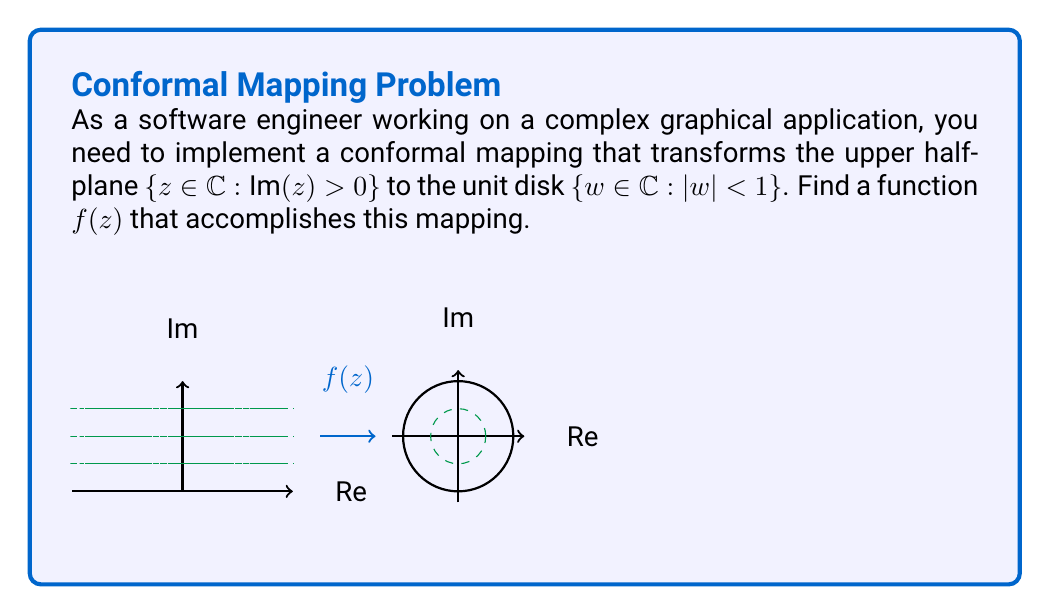Can you solve this math problem? Let's approach this step-by-step:

1) We need a function that maps the upper half-plane to the unit disk. A common function for this is the Möbius transformation.

2) The general form of a Möbius transformation is:

   $$f(z) = \frac{az + b}{cz + d}$$

   where $a$, $b$, $c$, and $d$ are complex constants and $ad - bc \neq 0$.

3) For our specific mapping, we can use:

   $$f(z) = \frac{z - i}{z + i}$$

4) Let's verify that this function indeed maps the upper half-plane to the unit disk:

   a) First, consider a point $z = x + yi$ in the upper half-plane. This means $y > 0$.

   b) Now, let's calculate $|f(z)|^2$:

      $$|f(z)|^2 = \left|\frac{z - i}{z + i}\right|^2 = \frac{(z - i)(\bar{z} + i)}{(z + i)(\bar{z} - i)}$$

      $$= \frac{(x+yi-i)(x-yi+i)}{(x+yi+i)(x-yi-i)} = \frac{x^2+y^2-2y+1}{x^2+y^2+2y+1}$$

   c) For this to be less than 1 (i.e., for the point to be inside the unit disk), we need:

      $$\frac{x^2+y^2-2y+1}{x^2+y^2+2y+1} < 1$$

      $$x^2+y^2-2y+1 < x^2+y^2+2y+1$$

      $$-2y < 2y$$

      $$0 < y$$

   d) This last inequality is true for all points in the upper half-plane.

5) We can also verify that this function maps the real axis to the unit circle:
   If $z = x$ (a real number), then:

   $$f(x) = \frac{x - i}{x + i}$$

   The magnitude of this complex number is always 1:

   $$\left|\frac{x - i}{x + i}\right| = \sqrt{\frac{x^2 + 1}{x^2 + 1}} = 1$$

Thus, we have verified that $f(z) = \frac{z - i}{z + i}$ maps the upper half-plane to the unit disk.
Answer: $f(z) = \frac{z - i}{z + i}$ 